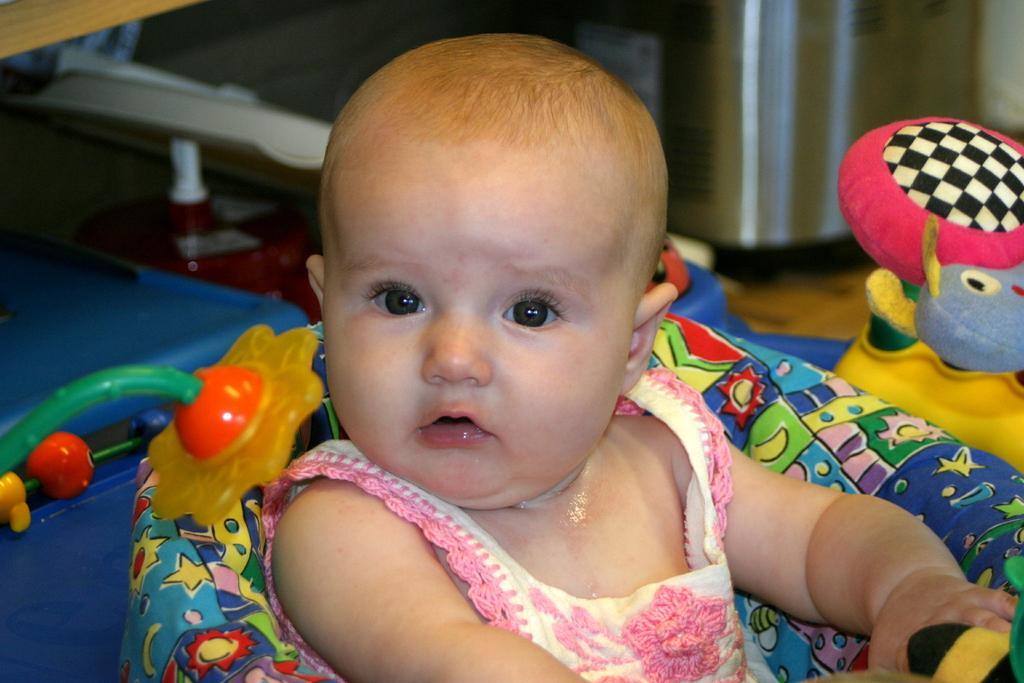Describe this image in one or two sentences. There is a baby inside a sitter in the foreground area of the image, there are some other objects and a toy in the background. 